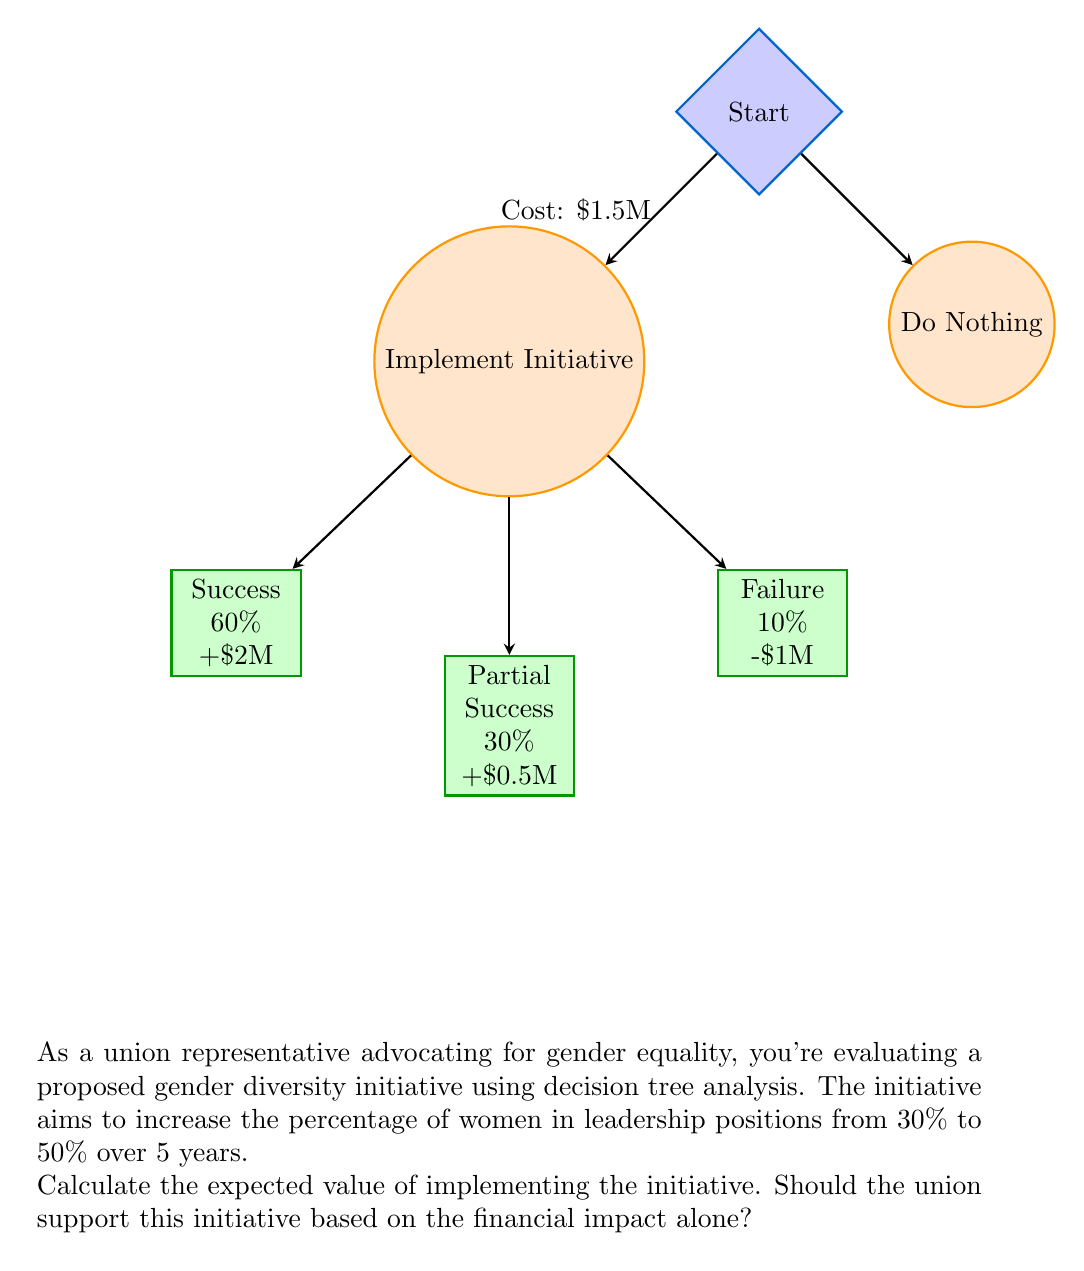Solve this math problem. To solve this problem, we'll use decision tree analysis and calculate the expected value of implementing the initiative:

1) First, let's calculate the expected value of implementing the initiative:

   Success: $0.60 \times \$2,000,000 = \$1,200,000$
   Partial Success: $0.30 \times \$500,000 = \$150,000$
   Failure: $0.10 \times (-\$1,000,000) = -\$100,000$

2) Sum these values:
   $\$1,200,000 + \$150,000 - \$100,000 = \$1,250,000$

3) This is the expected benefit. To get the expected value, we need to subtract the cost:
   $\$1,250,000 - \$1,500,000 = -\$250,000$

4) The expected value of implementing the initiative is $-\$250,000$.

5) The expected value of doing nothing is $\$0$.

Therefore, based solely on financial impact, the expected value of implementing the initiative ($-\$250,000$) is less than the expected value of doing nothing ($\$0$).

However, as a union representative advocating for gender equality, it's important to note that this analysis only considers financial impact. The non-financial benefits of increased gender diversity, such as improved decision-making, enhanced company reputation, and better representation, are not quantified here but are crucial factors to consider.
Answer: $-\$250,000$; financially, no. 